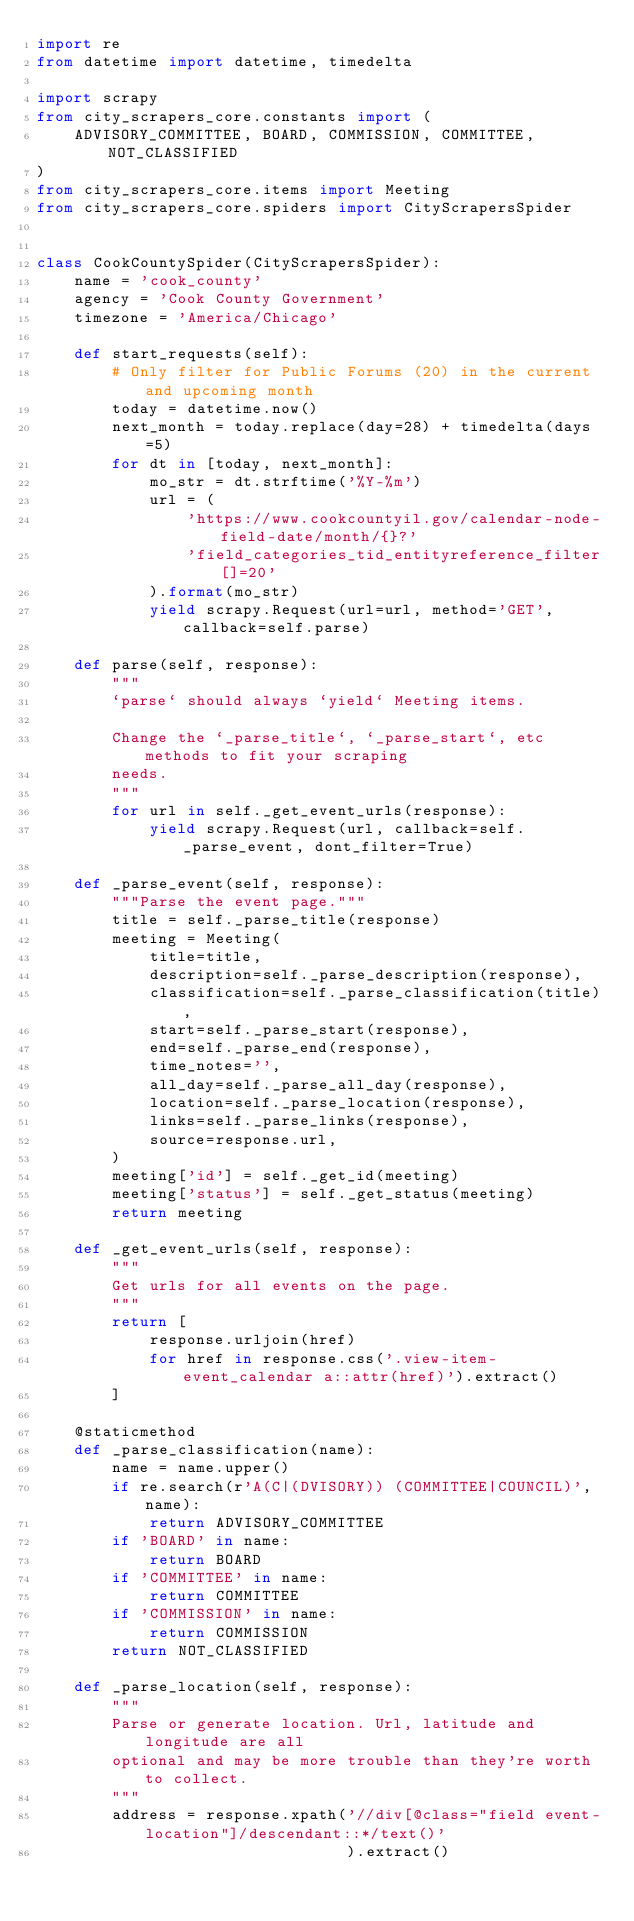Convert code to text. <code><loc_0><loc_0><loc_500><loc_500><_Python_>import re
from datetime import datetime, timedelta

import scrapy
from city_scrapers_core.constants import (
    ADVISORY_COMMITTEE, BOARD, COMMISSION, COMMITTEE, NOT_CLASSIFIED
)
from city_scrapers_core.items import Meeting
from city_scrapers_core.spiders import CityScrapersSpider


class CookCountySpider(CityScrapersSpider):
    name = 'cook_county'
    agency = 'Cook County Government'
    timezone = 'America/Chicago'

    def start_requests(self):
        # Only filter for Public Forums (20) in the current and upcoming month
        today = datetime.now()
        next_month = today.replace(day=28) + timedelta(days=5)
        for dt in [today, next_month]:
            mo_str = dt.strftime('%Y-%m')
            url = (
                'https://www.cookcountyil.gov/calendar-node-field-date/month/{}?'
                'field_categories_tid_entityreference_filter[]=20'
            ).format(mo_str)
            yield scrapy.Request(url=url, method='GET', callback=self.parse)

    def parse(self, response):
        """
        `parse` should always `yield` Meeting items.

        Change the `_parse_title`, `_parse_start`, etc methods to fit your scraping
        needs.
        """
        for url in self._get_event_urls(response):
            yield scrapy.Request(url, callback=self._parse_event, dont_filter=True)

    def _parse_event(self, response):
        """Parse the event page."""
        title = self._parse_title(response)
        meeting = Meeting(
            title=title,
            description=self._parse_description(response),
            classification=self._parse_classification(title),
            start=self._parse_start(response),
            end=self._parse_end(response),
            time_notes='',
            all_day=self._parse_all_day(response),
            location=self._parse_location(response),
            links=self._parse_links(response),
            source=response.url,
        )
        meeting['id'] = self._get_id(meeting)
        meeting['status'] = self._get_status(meeting)
        return meeting

    def _get_event_urls(self, response):
        """
        Get urls for all events on the page.
        """
        return [
            response.urljoin(href)
            for href in response.css('.view-item-event_calendar a::attr(href)').extract()
        ]

    @staticmethod
    def _parse_classification(name):
        name = name.upper()
        if re.search(r'A(C|(DVISORY)) (COMMITTEE|COUNCIL)', name):
            return ADVISORY_COMMITTEE
        if 'BOARD' in name:
            return BOARD
        if 'COMMITTEE' in name:
            return COMMITTEE
        if 'COMMISSION' in name:
            return COMMISSION
        return NOT_CLASSIFIED

    def _parse_location(self, response):
        """
        Parse or generate location. Url, latitude and longitude are all
        optional and may be more trouble than they're worth to collect.
        """
        address = response.xpath('//div[@class="field event-location"]/descendant::*/text()'
                                 ).extract()</code> 